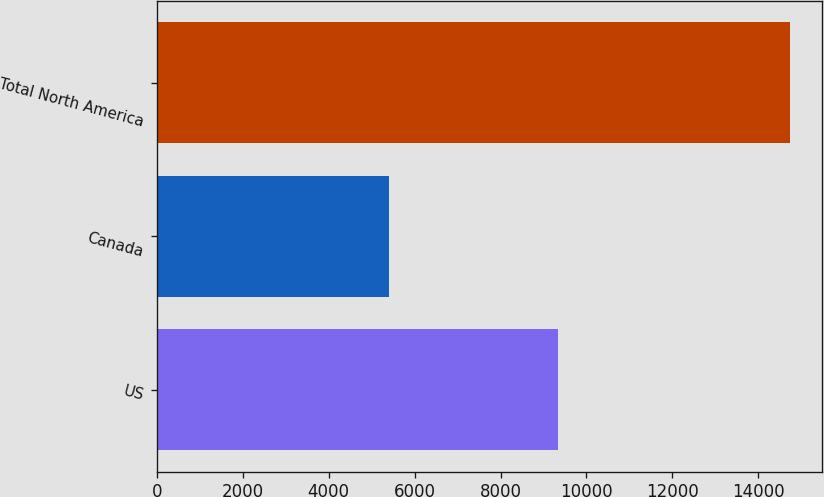Convert chart to OTSL. <chart><loc_0><loc_0><loc_500><loc_500><bar_chart><fcel>US<fcel>Canada<fcel>Total North America<nl><fcel>9328<fcel>5416<fcel>14744<nl></chart> 